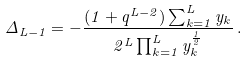<formula> <loc_0><loc_0><loc_500><loc_500>\Delta _ { L - 1 } = - \frac { ( 1 + q ^ { L - 2 } ) \sum _ { k = 1 } ^ { L } y _ { k } } { 2 ^ { L } \prod _ { k = 1 } ^ { L } y _ { k } ^ { \frac { 1 } { 2 } } } \, .</formula> 